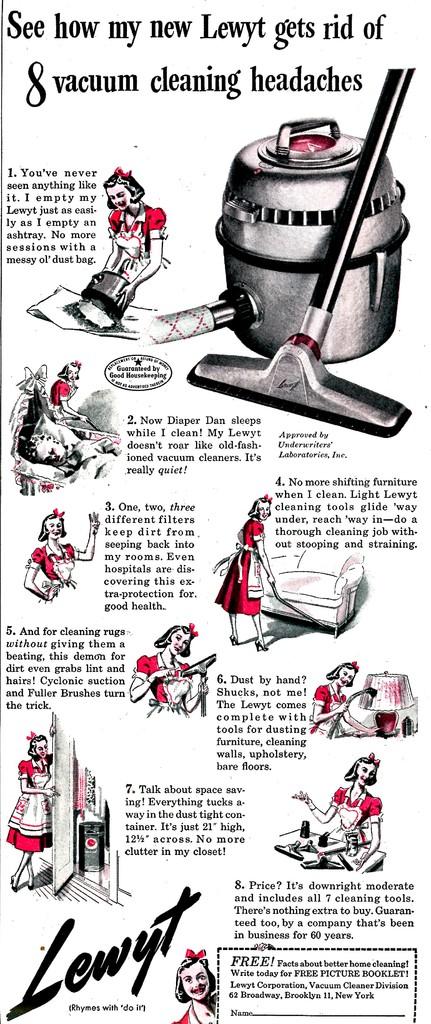Which brand is being advertised?
Your response must be concise. Lewyt. How many cleaning headaches?
Keep it short and to the point. 8. 